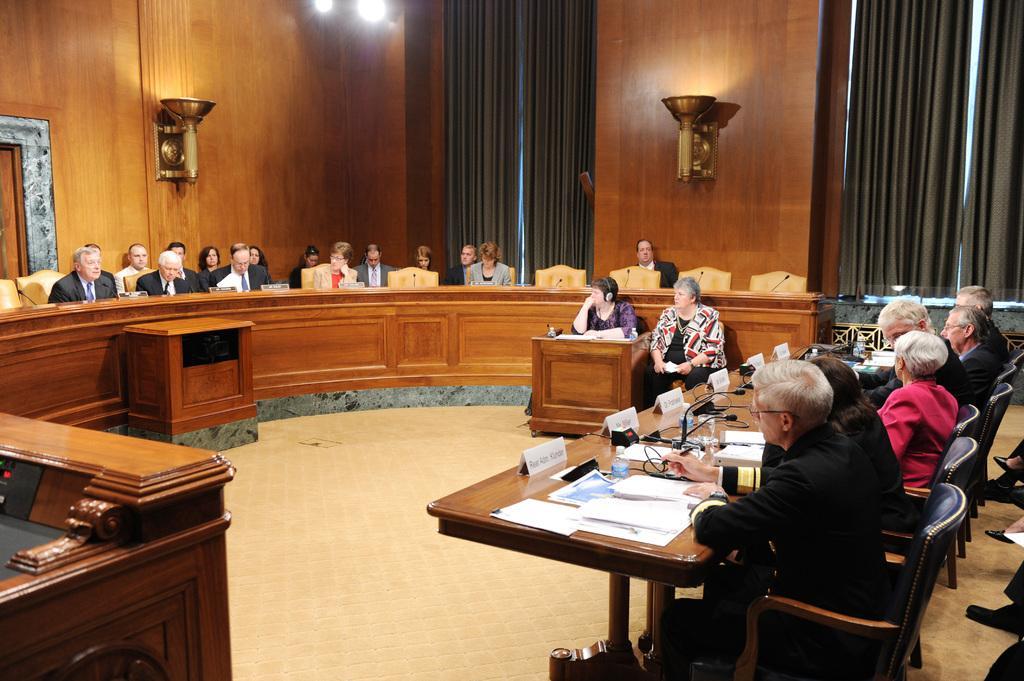Please provide a concise description of this image. In this image I can see number of people are sitting on chairs. On this table I can see few mice and few papers. In the background I can see curtains and few lights. 